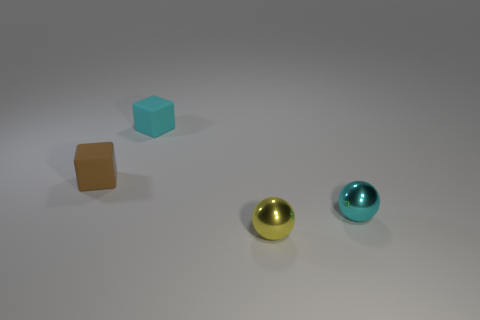The cyan rubber object has what shape?
Provide a succinct answer. Cube. The small block behind the brown block is what color?
Ensure brevity in your answer.  Cyan. There is a cyan thing that is in front of the brown matte block; is there a shiny thing behind it?
Give a very brief answer. No. What number of objects are rubber things behind the brown matte block or big purple things?
Offer a very short reply. 1. Is there any other thing that has the same size as the cyan matte object?
Ensure brevity in your answer.  Yes. There is a sphere that is to the left of the cyan thing in front of the tiny cyan block; what is its material?
Provide a short and direct response. Metal. Is the number of tiny shiny things that are behind the small cyan shiny ball the same as the number of tiny cyan metal balls left of the tiny yellow ball?
Offer a very short reply. Yes. What number of things are metal balls in front of the tiny cyan sphere or metal things on the left side of the small cyan ball?
Give a very brief answer. 1. What is the material of the tiny object that is in front of the cyan rubber object and to the left of the small yellow metallic ball?
Make the answer very short. Rubber. What size is the sphere right of the object that is in front of the cyan thing on the right side of the tiny cyan matte cube?
Your response must be concise. Small. 